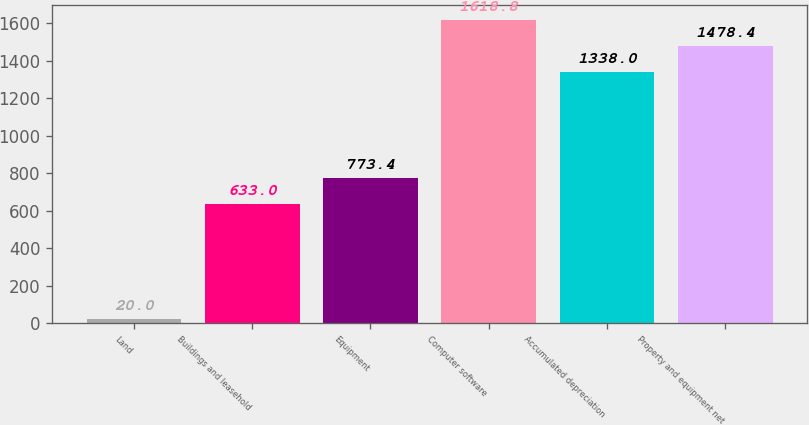<chart> <loc_0><loc_0><loc_500><loc_500><bar_chart><fcel>Land<fcel>Buildings and leasehold<fcel>Equipment<fcel>Computer software<fcel>Accumulated depreciation<fcel>Property and equipment net<nl><fcel>20<fcel>633<fcel>773.4<fcel>1618.8<fcel>1338<fcel>1478.4<nl></chart> 